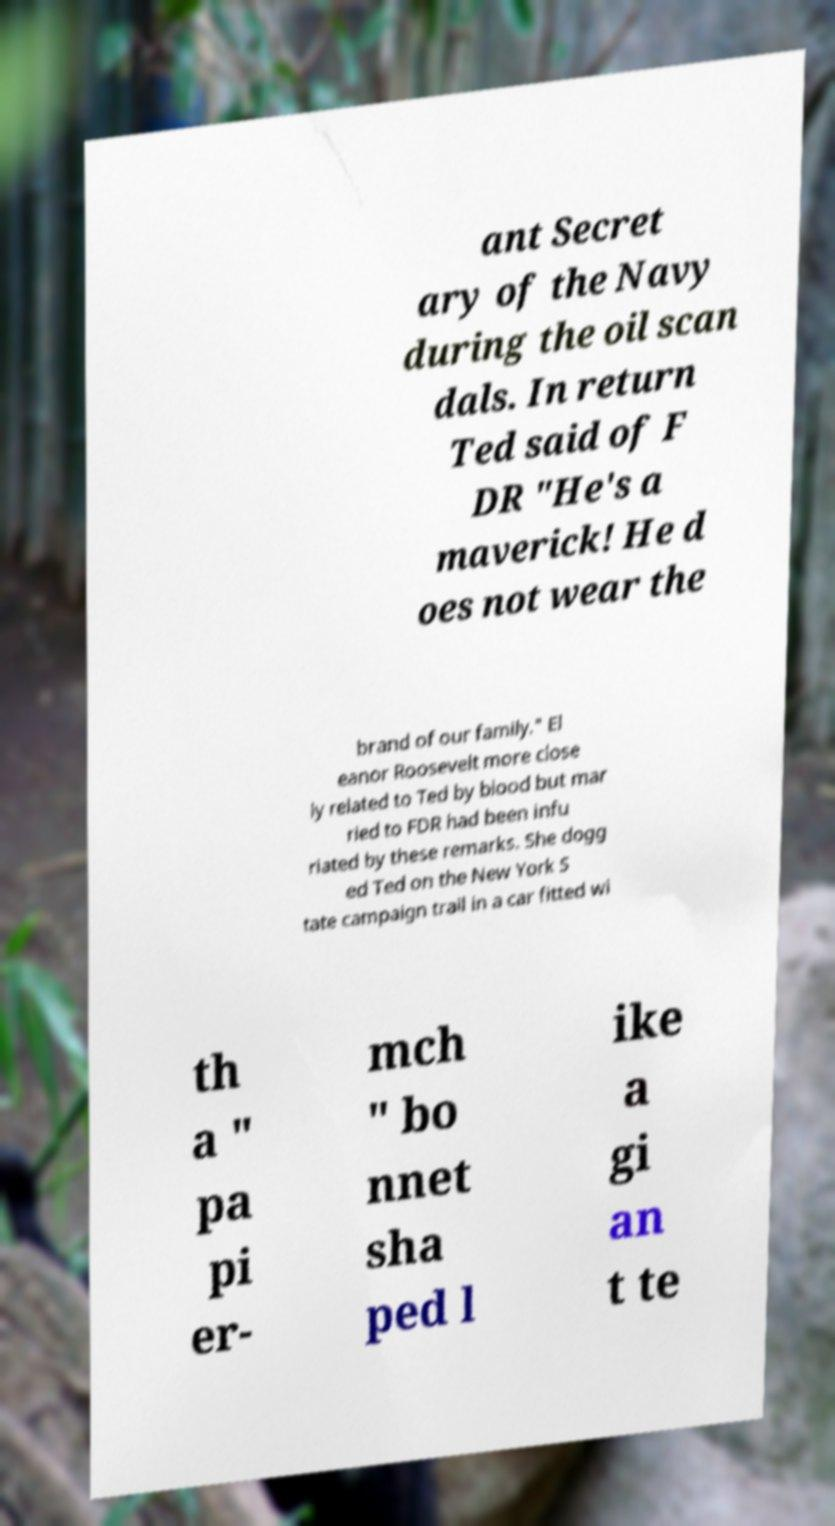For documentation purposes, I need the text within this image transcribed. Could you provide that? ant Secret ary of the Navy during the oil scan dals. In return Ted said of F DR "He's a maverick! He d oes not wear the brand of our family." El eanor Roosevelt more close ly related to Ted by blood but mar ried to FDR had been infu riated by these remarks. She dogg ed Ted on the New York S tate campaign trail in a car fitted wi th a " pa pi er- mch " bo nnet sha ped l ike a gi an t te 